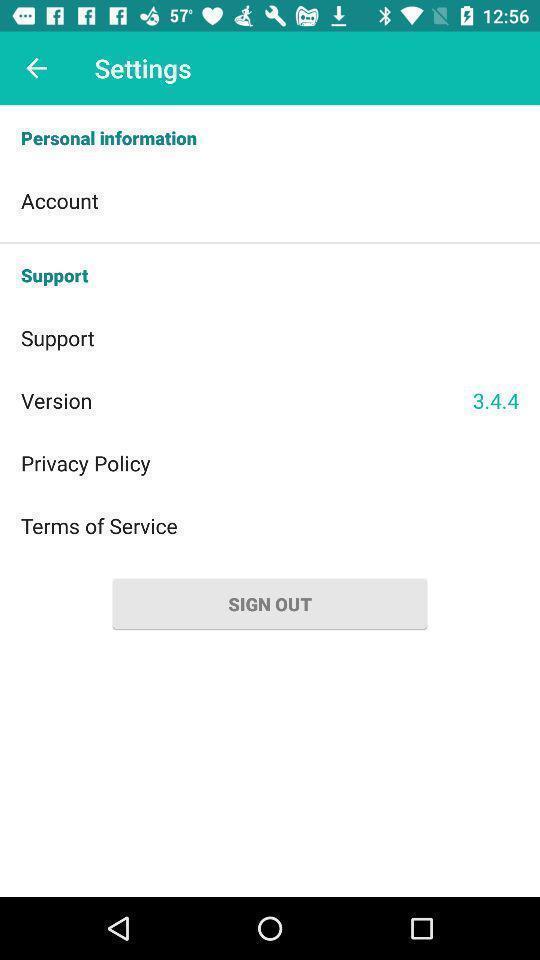Give me a narrative description of this picture. Screen displaying settings page. 